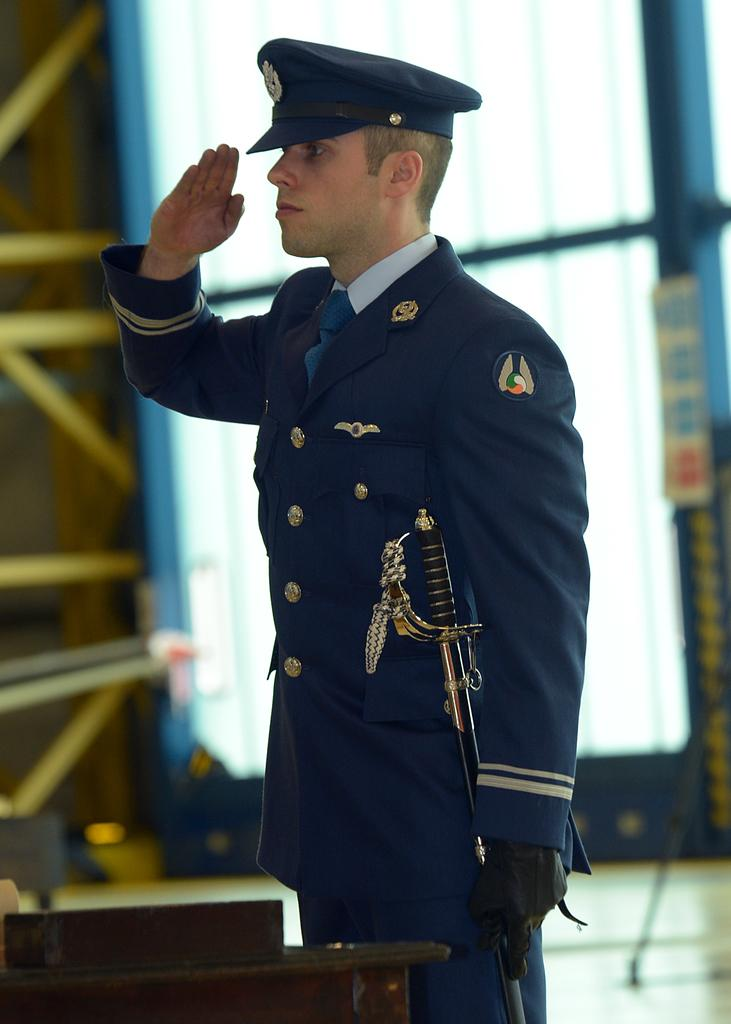Who is present in the image? There is a man in the image. What is the man doing with his hand? The man is saluting with his hand. What is the man wearing on his head? The man is wearing a cap on his head. What color is the coat the man is wearing? The man is wearing a blue coat. What object can be seen in the image that the man might be holding? There is a stick visible in the image, likely held by the man. How many clocks are visible on the man's wrist in the image? There are no clocks visible on the man's wrist in the image. What type of jewel is the man wearing around his neck in the image? There is no jewel visible around the man's neck in the image. 